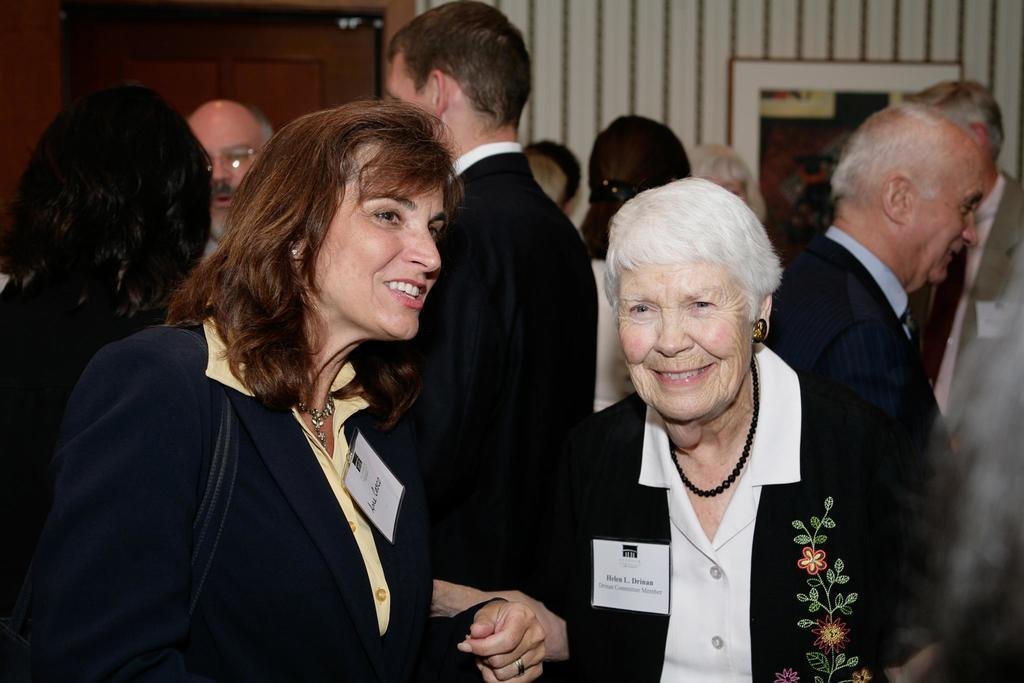Who or what is present in the image? There are people in the image. What can be seen in the background of the image? There is a wall and a door in the background of the image. Are there any cobwebs visible in the image? There is no mention of cobwebs in the provided facts, so we cannot determine if they are present in the image. 